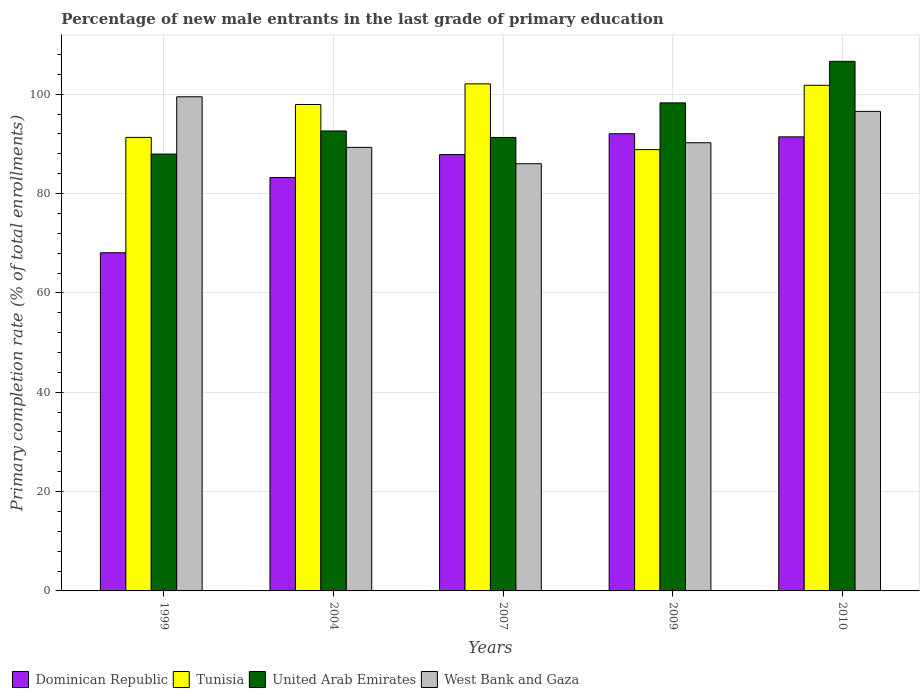How many different coloured bars are there?
Offer a terse response. 4. Are the number of bars on each tick of the X-axis equal?
Your answer should be compact. Yes. What is the label of the 1st group of bars from the left?
Provide a succinct answer. 1999. In how many cases, is the number of bars for a given year not equal to the number of legend labels?
Your response must be concise. 0. What is the percentage of new male entrants in West Bank and Gaza in 2007?
Your answer should be very brief. 86. Across all years, what is the maximum percentage of new male entrants in Tunisia?
Provide a succinct answer. 102.08. Across all years, what is the minimum percentage of new male entrants in Dominican Republic?
Your response must be concise. 68.07. In which year was the percentage of new male entrants in United Arab Emirates maximum?
Give a very brief answer. 2010. In which year was the percentage of new male entrants in West Bank and Gaza minimum?
Your answer should be very brief. 2007. What is the total percentage of new male entrants in United Arab Emirates in the graph?
Offer a very short reply. 476.69. What is the difference between the percentage of new male entrants in West Bank and Gaza in 1999 and that in 2010?
Make the answer very short. 2.94. What is the difference between the percentage of new male entrants in West Bank and Gaza in 2010 and the percentage of new male entrants in Tunisia in 2009?
Your answer should be compact. 7.69. What is the average percentage of new male entrants in United Arab Emirates per year?
Keep it short and to the point. 95.34. In the year 2004, what is the difference between the percentage of new male entrants in United Arab Emirates and percentage of new male entrants in West Bank and Gaza?
Your answer should be very brief. 3.3. What is the ratio of the percentage of new male entrants in Dominican Republic in 1999 to that in 2007?
Provide a succinct answer. 0.77. What is the difference between the highest and the second highest percentage of new male entrants in United Arab Emirates?
Offer a very short reply. 8.36. What is the difference between the highest and the lowest percentage of new male entrants in Tunisia?
Provide a short and direct response. 13.24. In how many years, is the percentage of new male entrants in United Arab Emirates greater than the average percentage of new male entrants in United Arab Emirates taken over all years?
Your answer should be compact. 2. Is the sum of the percentage of new male entrants in West Bank and Gaza in 2007 and 2010 greater than the maximum percentage of new male entrants in Tunisia across all years?
Keep it short and to the point. Yes. What does the 1st bar from the left in 2009 represents?
Offer a very short reply. Dominican Republic. What does the 1st bar from the right in 2009 represents?
Provide a short and direct response. West Bank and Gaza. Is it the case that in every year, the sum of the percentage of new male entrants in Dominican Republic and percentage of new male entrants in West Bank and Gaza is greater than the percentage of new male entrants in Tunisia?
Your response must be concise. Yes. How many bars are there?
Your answer should be compact. 20. Are all the bars in the graph horizontal?
Make the answer very short. No. How many years are there in the graph?
Your response must be concise. 5. Does the graph contain grids?
Your response must be concise. Yes. What is the title of the graph?
Make the answer very short. Percentage of new male entrants in the last grade of primary education. Does "Euro area" appear as one of the legend labels in the graph?
Ensure brevity in your answer.  No. What is the label or title of the X-axis?
Your answer should be compact. Years. What is the label or title of the Y-axis?
Offer a terse response. Primary completion rate (% of total enrollments). What is the Primary completion rate (% of total enrollments) of Dominican Republic in 1999?
Offer a very short reply. 68.07. What is the Primary completion rate (% of total enrollments) of Tunisia in 1999?
Ensure brevity in your answer.  91.3. What is the Primary completion rate (% of total enrollments) of United Arab Emirates in 1999?
Your response must be concise. 87.95. What is the Primary completion rate (% of total enrollments) in West Bank and Gaza in 1999?
Make the answer very short. 99.48. What is the Primary completion rate (% of total enrollments) in Dominican Republic in 2004?
Give a very brief answer. 83.22. What is the Primary completion rate (% of total enrollments) of Tunisia in 2004?
Ensure brevity in your answer.  97.93. What is the Primary completion rate (% of total enrollments) of United Arab Emirates in 2004?
Make the answer very short. 92.6. What is the Primary completion rate (% of total enrollments) in West Bank and Gaza in 2004?
Provide a succinct answer. 89.29. What is the Primary completion rate (% of total enrollments) in Dominican Republic in 2007?
Offer a terse response. 87.84. What is the Primary completion rate (% of total enrollments) of Tunisia in 2007?
Provide a succinct answer. 102.08. What is the Primary completion rate (% of total enrollments) of United Arab Emirates in 2007?
Offer a terse response. 91.29. What is the Primary completion rate (% of total enrollments) of West Bank and Gaza in 2007?
Keep it short and to the point. 86. What is the Primary completion rate (% of total enrollments) of Dominican Republic in 2009?
Provide a short and direct response. 92.04. What is the Primary completion rate (% of total enrollments) in Tunisia in 2009?
Offer a very short reply. 88.84. What is the Primary completion rate (% of total enrollments) of United Arab Emirates in 2009?
Your response must be concise. 98.25. What is the Primary completion rate (% of total enrollments) in West Bank and Gaza in 2009?
Keep it short and to the point. 90.22. What is the Primary completion rate (% of total enrollments) in Dominican Republic in 2010?
Provide a succinct answer. 91.41. What is the Primary completion rate (% of total enrollments) of Tunisia in 2010?
Provide a short and direct response. 101.79. What is the Primary completion rate (% of total enrollments) in United Arab Emirates in 2010?
Your answer should be very brief. 106.61. What is the Primary completion rate (% of total enrollments) of West Bank and Gaza in 2010?
Offer a very short reply. 96.54. Across all years, what is the maximum Primary completion rate (% of total enrollments) in Dominican Republic?
Your answer should be very brief. 92.04. Across all years, what is the maximum Primary completion rate (% of total enrollments) in Tunisia?
Provide a short and direct response. 102.08. Across all years, what is the maximum Primary completion rate (% of total enrollments) of United Arab Emirates?
Provide a short and direct response. 106.61. Across all years, what is the maximum Primary completion rate (% of total enrollments) of West Bank and Gaza?
Your answer should be very brief. 99.48. Across all years, what is the minimum Primary completion rate (% of total enrollments) in Dominican Republic?
Make the answer very short. 68.07. Across all years, what is the minimum Primary completion rate (% of total enrollments) in Tunisia?
Your answer should be very brief. 88.84. Across all years, what is the minimum Primary completion rate (% of total enrollments) of United Arab Emirates?
Provide a short and direct response. 87.95. Across all years, what is the minimum Primary completion rate (% of total enrollments) in West Bank and Gaza?
Your answer should be compact. 86. What is the total Primary completion rate (% of total enrollments) of Dominican Republic in the graph?
Offer a terse response. 422.58. What is the total Primary completion rate (% of total enrollments) of Tunisia in the graph?
Offer a very short reply. 481.94. What is the total Primary completion rate (% of total enrollments) of United Arab Emirates in the graph?
Provide a succinct answer. 476.69. What is the total Primary completion rate (% of total enrollments) of West Bank and Gaza in the graph?
Provide a short and direct response. 461.53. What is the difference between the Primary completion rate (% of total enrollments) in Dominican Republic in 1999 and that in 2004?
Your answer should be compact. -15.15. What is the difference between the Primary completion rate (% of total enrollments) in Tunisia in 1999 and that in 2004?
Keep it short and to the point. -6.62. What is the difference between the Primary completion rate (% of total enrollments) of United Arab Emirates in 1999 and that in 2004?
Offer a very short reply. -4.65. What is the difference between the Primary completion rate (% of total enrollments) of West Bank and Gaza in 1999 and that in 2004?
Offer a terse response. 10.18. What is the difference between the Primary completion rate (% of total enrollments) of Dominican Republic in 1999 and that in 2007?
Offer a terse response. -19.77. What is the difference between the Primary completion rate (% of total enrollments) of Tunisia in 1999 and that in 2007?
Ensure brevity in your answer.  -10.78. What is the difference between the Primary completion rate (% of total enrollments) of United Arab Emirates in 1999 and that in 2007?
Offer a terse response. -3.34. What is the difference between the Primary completion rate (% of total enrollments) of West Bank and Gaza in 1999 and that in 2007?
Your answer should be compact. 13.48. What is the difference between the Primary completion rate (% of total enrollments) of Dominican Republic in 1999 and that in 2009?
Your response must be concise. -23.96. What is the difference between the Primary completion rate (% of total enrollments) in Tunisia in 1999 and that in 2009?
Offer a very short reply. 2.46. What is the difference between the Primary completion rate (% of total enrollments) in United Arab Emirates in 1999 and that in 2009?
Provide a short and direct response. -10.3. What is the difference between the Primary completion rate (% of total enrollments) of West Bank and Gaza in 1999 and that in 2009?
Keep it short and to the point. 9.25. What is the difference between the Primary completion rate (% of total enrollments) of Dominican Republic in 1999 and that in 2010?
Your response must be concise. -23.34. What is the difference between the Primary completion rate (% of total enrollments) in Tunisia in 1999 and that in 2010?
Your response must be concise. -10.49. What is the difference between the Primary completion rate (% of total enrollments) of United Arab Emirates in 1999 and that in 2010?
Provide a succinct answer. -18.66. What is the difference between the Primary completion rate (% of total enrollments) of West Bank and Gaza in 1999 and that in 2010?
Your answer should be compact. 2.94. What is the difference between the Primary completion rate (% of total enrollments) in Dominican Republic in 2004 and that in 2007?
Offer a very short reply. -4.62. What is the difference between the Primary completion rate (% of total enrollments) of Tunisia in 2004 and that in 2007?
Ensure brevity in your answer.  -4.16. What is the difference between the Primary completion rate (% of total enrollments) in United Arab Emirates in 2004 and that in 2007?
Offer a terse response. 1.31. What is the difference between the Primary completion rate (% of total enrollments) of West Bank and Gaza in 2004 and that in 2007?
Your response must be concise. 3.3. What is the difference between the Primary completion rate (% of total enrollments) in Dominican Republic in 2004 and that in 2009?
Offer a very short reply. -8.82. What is the difference between the Primary completion rate (% of total enrollments) in Tunisia in 2004 and that in 2009?
Keep it short and to the point. 9.08. What is the difference between the Primary completion rate (% of total enrollments) in United Arab Emirates in 2004 and that in 2009?
Keep it short and to the point. -5.65. What is the difference between the Primary completion rate (% of total enrollments) in West Bank and Gaza in 2004 and that in 2009?
Ensure brevity in your answer.  -0.93. What is the difference between the Primary completion rate (% of total enrollments) in Dominican Republic in 2004 and that in 2010?
Ensure brevity in your answer.  -8.19. What is the difference between the Primary completion rate (% of total enrollments) of Tunisia in 2004 and that in 2010?
Your answer should be compact. -3.86. What is the difference between the Primary completion rate (% of total enrollments) of United Arab Emirates in 2004 and that in 2010?
Your answer should be very brief. -14.01. What is the difference between the Primary completion rate (% of total enrollments) in West Bank and Gaza in 2004 and that in 2010?
Your answer should be very brief. -7.24. What is the difference between the Primary completion rate (% of total enrollments) of Dominican Republic in 2007 and that in 2009?
Ensure brevity in your answer.  -4.2. What is the difference between the Primary completion rate (% of total enrollments) of Tunisia in 2007 and that in 2009?
Offer a terse response. 13.24. What is the difference between the Primary completion rate (% of total enrollments) of United Arab Emirates in 2007 and that in 2009?
Offer a very short reply. -6.96. What is the difference between the Primary completion rate (% of total enrollments) in West Bank and Gaza in 2007 and that in 2009?
Your answer should be very brief. -4.23. What is the difference between the Primary completion rate (% of total enrollments) in Dominican Republic in 2007 and that in 2010?
Make the answer very short. -3.57. What is the difference between the Primary completion rate (% of total enrollments) of Tunisia in 2007 and that in 2010?
Make the answer very short. 0.29. What is the difference between the Primary completion rate (% of total enrollments) of United Arab Emirates in 2007 and that in 2010?
Keep it short and to the point. -15.32. What is the difference between the Primary completion rate (% of total enrollments) in West Bank and Gaza in 2007 and that in 2010?
Provide a short and direct response. -10.54. What is the difference between the Primary completion rate (% of total enrollments) of Dominican Republic in 2009 and that in 2010?
Your answer should be compact. 0.62. What is the difference between the Primary completion rate (% of total enrollments) in Tunisia in 2009 and that in 2010?
Provide a succinct answer. -12.95. What is the difference between the Primary completion rate (% of total enrollments) in United Arab Emirates in 2009 and that in 2010?
Your answer should be compact. -8.36. What is the difference between the Primary completion rate (% of total enrollments) of West Bank and Gaza in 2009 and that in 2010?
Provide a short and direct response. -6.31. What is the difference between the Primary completion rate (% of total enrollments) in Dominican Republic in 1999 and the Primary completion rate (% of total enrollments) in Tunisia in 2004?
Offer a very short reply. -29.85. What is the difference between the Primary completion rate (% of total enrollments) of Dominican Republic in 1999 and the Primary completion rate (% of total enrollments) of United Arab Emirates in 2004?
Ensure brevity in your answer.  -24.52. What is the difference between the Primary completion rate (% of total enrollments) in Dominican Republic in 1999 and the Primary completion rate (% of total enrollments) in West Bank and Gaza in 2004?
Your answer should be very brief. -21.22. What is the difference between the Primary completion rate (% of total enrollments) in Tunisia in 1999 and the Primary completion rate (% of total enrollments) in United Arab Emirates in 2004?
Keep it short and to the point. -1.29. What is the difference between the Primary completion rate (% of total enrollments) of Tunisia in 1999 and the Primary completion rate (% of total enrollments) of West Bank and Gaza in 2004?
Make the answer very short. 2.01. What is the difference between the Primary completion rate (% of total enrollments) of United Arab Emirates in 1999 and the Primary completion rate (% of total enrollments) of West Bank and Gaza in 2004?
Your answer should be very brief. -1.35. What is the difference between the Primary completion rate (% of total enrollments) of Dominican Republic in 1999 and the Primary completion rate (% of total enrollments) of Tunisia in 2007?
Your answer should be very brief. -34.01. What is the difference between the Primary completion rate (% of total enrollments) of Dominican Republic in 1999 and the Primary completion rate (% of total enrollments) of United Arab Emirates in 2007?
Ensure brevity in your answer.  -23.21. What is the difference between the Primary completion rate (% of total enrollments) in Dominican Republic in 1999 and the Primary completion rate (% of total enrollments) in West Bank and Gaza in 2007?
Your answer should be compact. -17.92. What is the difference between the Primary completion rate (% of total enrollments) in Tunisia in 1999 and the Primary completion rate (% of total enrollments) in United Arab Emirates in 2007?
Ensure brevity in your answer.  0.01. What is the difference between the Primary completion rate (% of total enrollments) in Tunisia in 1999 and the Primary completion rate (% of total enrollments) in West Bank and Gaza in 2007?
Ensure brevity in your answer.  5.3. What is the difference between the Primary completion rate (% of total enrollments) in United Arab Emirates in 1999 and the Primary completion rate (% of total enrollments) in West Bank and Gaza in 2007?
Give a very brief answer. 1.95. What is the difference between the Primary completion rate (% of total enrollments) in Dominican Republic in 1999 and the Primary completion rate (% of total enrollments) in Tunisia in 2009?
Provide a succinct answer. -20.77. What is the difference between the Primary completion rate (% of total enrollments) in Dominican Republic in 1999 and the Primary completion rate (% of total enrollments) in United Arab Emirates in 2009?
Offer a terse response. -30.18. What is the difference between the Primary completion rate (% of total enrollments) in Dominican Republic in 1999 and the Primary completion rate (% of total enrollments) in West Bank and Gaza in 2009?
Your answer should be compact. -22.15. What is the difference between the Primary completion rate (% of total enrollments) of Tunisia in 1999 and the Primary completion rate (% of total enrollments) of United Arab Emirates in 2009?
Make the answer very short. -6.95. What is the difference between the Primary completion rate (% of total enrollments) in Tunisia in 1999 and the Primary completion rate (% of total enrollments) in West Bank and Gaza in 2009?
Offer a very short reply. 1.08. What is the difference between the Primary completion rate (% of total enrollments) in United Arab Emirates in 1999 and the Primary completion rate (% of total enrollments) in West Bank and Gaza in 2009?
Offer a terse response. -2.28. What is the difference between the Primary completion rate (% of total enrollments) in Dominican Republic in 1999 and the Primary completion rate (% of total enrollments) in Tunisia in 2010?
Make the answer very short. -33.72. What is the difference between the Primary completion rate (% of total enrollments) of Dominican Republic in 1999 and the Primary completion rate (% of total enrollments) of United Arab Emirates in 2010?
Your response must be concise. -38.54. What is the difference between the Primary completion rate (% of total enrollments) in Dominican Republic in 1999 and the Primary completion rate (% of total enrollments) in West Bank and Gaza in 2010?
Ensure brevity in your answer.  -28.46. What is the difference between the Primary completion rate (% of total enrollments) of Tunisia in 1999 and the Primary completion rate (% of total enrollments) of United Arab Emirates in 2010?
Your response must be concise. -15.31. What is the difference between the Primary completion rate (% of total enrollments) in Tunisia in 1999 and the Primary completion rate (% of total enrollments) in West Bank and Gaza in 2010?
Your response must be concise. -5.24. What is the difference between the Primary completion rate (% of total enrollments) in United Arab Emirates in 1999 and the Primary completion rate (% of total enrollments) in West Bank and Gaza in 2010?
Ensure brevity in your answer.  -8.59. What is the difference between the Primary completion rate (% of total enrollments) in Dominican Republic in 2004 and the Primary completion rate (% of total enrollments) in Tunisia in 2007?
Your response must be concise. -18.86. What is the difference between the Primary completion rate (% of total enrollments) in Dominican Republic in 2004 and the Primary completion rate (% of total enrollments) in United Arab Emirates in 2007?
Give a very brief answer. -8.07. What is the difference between the Primary completion rate (% of total enrollments) of Dominican Republic in 2004 and the Primary completion rate (% of total enrollments) of West Bank and Gaza in 2007?
Ensure brevity in your answer.  -2.78. What is the difference between the Primary completion rate (% of total enrollments) of Tunisia in 2004 and the Primary completion rate (% of total enrollments) of United Arab Emirates in 2007?
Give a very brief answer. 6.64. What is the difference between the Primary completion rate (% of total enrollments) in Tunisia in 2004 and the Primary completion rate (% of total enrollments) in West Bank and Gaza in 2007?
Offer a very short reply. 11.93. What is the difference between the Primary completion rate (% of total enrollments) in United Arab Emirates in 2004 and the Primary completion rate (% of total enrollments) in West Bank and Gaza in 2007?
Offer a very short reply. 6.6. What is the difference between the Primary completion rate (% of total enrollments) of Dominican Republic in 2004 and the Primary completion rate (% of total enrollments) of Tunisia in 2009?
Provide a short and direct response. -5.62. What is the difference between the Primary completion rate (% of total enrollments) in Dominican Republic in 2004 and the Primary completion rate (% of total enrollments) in United Arab Emirates in 2009?
Offer a very short reply. -15.03. What is the difference between the Primary completion rate (% of total enrollments) of Dominican Republic in 2004 and the Primary completion rate (% of total enrollments) of West Bank and Gaza in 2009?
Provide a succinct answer. -7. What is the difference between the Primary completion rate (% of total enrollments) in Tunisia in 2004 and the Primary completion rate (% of total enrollments) in United Arab Emirates in 2009?
Your response must be concise. -0.32. What is the difference between the Primary completion rate (% of total enrollments) in Tunisia in 2004 and the Primary completion rate (% of total enrollments) in West Bank and Gaza in 2009?
Ensure brevity in your answer.  7.7. What is the difference between the Primary completion rate (% of total enrollments) in United Arab Emirates in 2004 and the Primary completion rate (% of total enrollments) in West Bank and Gaza in 2009?
Ensure brevity in your answer.  2.37. What is the difference between the Primary completion rate (% of total enrollments) of Dominican Republic in 2004 and the Primary completion rate (% of total enrollments) of Tunisia in 2010?
Offer a terse response. -18.57. What is the difference between the Primary completion rate (% of total enrollments) of Dominican Republic in 2004 and the Primary completion rate (% of total enrollments) of United Arab Emirates in 2010?
Ensure brevity in your answer.  -23.39. What is the difference between the Primary completion rate (% of total enrollments) in Dominican Republic in 2004 and the Primary completion rate (% of total enrollments) in West Bank and Gaza in 2010?
Your answer should be compact. -13.32. What is the difference between the Primary completion rate (% of total enrollments) of Tunisia in 2004 and the Primary completion rate (% of total enrollments) of United Arab Emirates in 2010?
Offer a very short reply. -8.68. What is the difference between the Primary completion rate (% of total enrollments) in Tunisia in 2004 and the Primary completion rate (% of total enrollments) in West Bank and Gaza in 2010?
Offer a terse response. 1.39. What is the difference between the Primary completion rate (% of total enrollments) of United Arab Emirates in 2004 and the Primary completion rate (% of total enrollments) of West Bank and Gaza in 2010?
Keep it short and to the point. -3.94. What is the difference between the Primary completion rate (% of total enrollments) of Dominican Republic in 2007 and the Primary completion rate (% of total enrollments) of Tunisia in 2009?
Give a very brief answer. -1.01. What is the difference between the Primary completion rate (% of total enrollments) in Dominican Republic in 2007 and the Primary completion rate (% of total enrollments) in United Arab Emirates in 2009?
Provide a short and direct response. -10.41. What is the difference between the Primary completion rate (% of total enrollments) of Dominican Republic in 2007 and the Primary completion rate (% of total enrollments) of West Bank and Gaza in 2009?
Offer a very short reply. -2.38. What is the difference between the Primary completion rate (% of total enrollments) in Tunisia in 2007 and the Primary completion rate (% of total enrollments) in United Arab Emirates in 2009?
Make the answer very short. 3.83. What is the difference between the Primary completion rate (% of total enrollments) in Tunisia in 2007 and the Primary completion rate (% of total enrollments) in West Bank and Gaza in 2009?
Make the answer very short. 11.86. What is the difference between the Primary completion rate (% of total enrollments) of United Arab Emirates in 2007 and the Primary completion rate (% of total enrollments) of West Bank and Gaza in 2009?
Make the answer very short. 1.06. What is the difference between the Primary completion rate (% of total enrollments) of Dominican Republic in 2007 and the Primary completion rate (% of total enrollments) of Tunisia in 2010?
Provide a short and direct response. -13.95. What is the difference between the Primary completion rate (% of total enrollments) in Dominican Republic in 2007 and the Primary completion rate (% of total enrollments) in United Arab Emirates in 2010?
Your answer should be very brief. -18.77. What is the difference between the Primary completion rate (% of total enrollments) in Dominican Republic in 2007 and the Primary completion rate (% of total enrollments) in West Bank and Gaza in 2010?
Your answer should be very brief. -8.7. What is the difference between the Primary completion rate (% of total enrollments) of Tunisia in 2007 and the Primary completion rate (% of total enrollments) of United Arab Emirates in 2010?
Offer a very short reply. -4.53. What is the difference between the Primary completion rate (% of total enrollments) of Tunisia in 2007 and the Primary completion rate (% of total enrollments) of West Bank and Gaza in 2010?
Give a very brief answer. 5.54. What is the difference between the Primary completion rate (% of total enrollments) of United Arab Emirates in 2007 and the Primary completion rate (% of total enrollments) of West Bank and Gaza in 2010?
Ensure brevity in your answer.  -5.25. What is the difference between the Primary completion rate (% of total enrollments) of Dominican Republic in 2009 and the Primary completion rate (% of total enrollments) of Tunisia in 2010?
Provide a succinct answer. -9.75. What is the difference between the Primary completion rate (% of total enrollments) in Dominican Republic in 2009 and the Primary completion rate (% of total enrollments) in United Arab Emirates in 2010?
Offer a very short reply. -14.57. What is the difference between the Primary completion rate (% of total enrollments) of Dominican Republic in 2009 and the Primary completion rate (% of total enrollments) of West Bank and Gaza in 2010?
Offer a terse response. -4.5. What is the difference between the Primary completion rate (% of total enrollments) in Tunisia in 2009 and the Primary completion rate (% of total enrollments) in United Arab Emirates in 2010?
Provide a succinct answer. -17.77. What is the difference between the Primary completion rate (% of total enrollments) of Tunisia in 2009 and the Primary completion rate (% of total enrollments) of West Bank and Gaza in 2010?
Provide a short and direct response. -7.69. What is the difference between the Primary completion rate (% of total enrollments) of United Arab Emirates in 2009 and the Primary completion rate (% of total enrollments) of West Bank and Gaza in 2010?
Offer a very short reply. 1.71. What is the average Primary completion rate (% of total enrollments) in Dominican Republic per year?
Provide a short and direct response. 84.52. What is the average Primary completion rate (% of total enrollments) in Tunisia per year?
Keep it short and to the point. 96.39. What is the average Primary completion rate (% of total enrollments) in United Arab Emirates per year?
Keep it short and to the point. 95.34. What is the average Primary completion rate (% of total enrollments) of West Bank and Gaza per year?
Provide a succinct answer. 92.31. In the year 1999, what is the difference between the Primary completion rate (% of total enrollments) in Dominican Republic and Primary completion rate (% of total enrollments) in Tunisia?
Give a very brief answer. -23.23. In the year 1999, what is the difference between the Primary completion rate (% of total enrollments) of Dominican Republic and Primary completion rate (% of total enrollments) of United Arab Emirates?
Give a very brief answer. -19.87. In the year 1999, what is the difference between the Primary completion rate (% of total enrollments) in Dominican Republic and Primary completion rate (% of total enrollments) in West Bank and Gaza?
Make the answer very short. -31.4. In the year 1999, what is the difference between the Primary completion rate (% of total enrollments) of Tunisia and Primary completion rate (% of total enrollments) of United Arab Emirates?
Ensure brevity in your answer.  3.35. In the year 1999, what is the difference between the Primary completion rate (% of total enrollments) in Tunisia and Primary completion rate (% of total enrollments) in West Bank and Gaza?
Your answer should be very brief. -8.18. In the year 1999, what is the difference between the Primary completion rate (% of total enrollments) of United Arab Emirates and Primary completion rate (% of total enrollments) of West Bank and Gaza?
Give a very brief answer. -11.53. In the year 2004, what is the difference between the Primary completion rate (% of total enrollments) in Dominican Republic and Primary completion rate (% of total enrollments) in Tunisia?
Offer a very short reply. -14.71. In the year 2004, what is the difference between the Primary completion rate (% of total enrollments) in Dominican Republic and Primary completion rate (% of total enrollments) in United Arab Emirates?
Your answer should be compact. -9.38. In the year 2004, what is the difference between the Primary completion rate (% of total enrollments) in Dominican Republic and Primary completion rate (% of total enrollments) in West Bank and Gaza?
Give a very brief answer. -6.07. In the year 2004, what is the difference between the Primary completion rate (% of total enrollments) of Tunisia and Primary completion rate (% of total enrollments) of United Arab Emirates?
Offer a terse response. 5.33. In the year 2004, what is the difference between the Primary completion rate (% of total enrollments) of Tunisia and Primary completion rate (% of total enrollments) of West Bank and Gaza?
Ensure brevity in your answer.  8.63. In the year 2004, what is the difference between the Primary completion rate (% of total enrollments) of United Arab Emirates and Primary completion rate (% of total enrollments) of West Bank and Gaza?
Offer a very short reply. 3.3. In the year 2007, what is the difference between the Primary completion rate (% of total enrollments) in Dominican Republic and Primary completion rate (% of total enrollments) in Tunisia?
Give a very brief answer. -14.24. In the year 2007, what is the difference between the Primary completion rate (% of total enrollments) of Dominican Republic and Primary completion rate (% of total enrollments) of United Arab Emirates?
Give a very brief answer. -3.45. In the year 2007, what is the difference between the Primary completion rate (% of total enrollments) in Dominican Republic and Primary completion rate (% of total enrollments) in West Bank and Gaza?
Your answer should be compact. 1.84. In the year 2007, what is the difference between the Primary completion rate (% of total enrollments) in Tunisia and Primary completion rate (% of total enrollments) in United Arab Emirates?
Your answer should be compact. 10.79. In the year 2007, what is the difference between the Primary completion rate (% of total enrollments) of Tunisia and Primary completion rate (% of total enrollments) of West Bank and Gaza?
Your answer should be compact. 16.08. In the year 2007, what is the difference between the Primary completion rate (% of total enrollments) in United Arab Emirates and Primary completion rate (% of total enrollments) in West Bank and Gaza?
Your answer should be very brief. 5.29. In the year 2009, what is the difference between the Primary completion rate (% of total enrollments) in Dominican Republic and Primary completion rate (% of total enrollments) in Tunisia?
Give a very brief answer. 3.19. In the year 2009, what is the difference between the Primary completion rate (% of total enrollments) of Dominican Republic and Primary completion rate (% of total enrollments) of United Arab Emirates?
Provide a short and direct response. -6.21. In the year 2009, what is the difference between the Primary completion rate (% of total enrollments) in Dominican Republic and Primary completion rate (% of total enrollments) in West Bank and Gaza?
Offer a very short reply. 1.81. In the year 2009, what is the difference between the Primary completion rate (% of total enrollments) in Tunisia and Primary completion rate (% of total enrollments) in United Arab Emirates?
Offer a very short reply. -9.4. In the year 2009, what is the difference between the Primary completion rate (% of total enrollments) in Tunisia and Primary completion rate (% of total enrollments) in West Bank and Gaza?
Your response must be concise. -1.38. In the year 2009, what is the difference between the Primary completion rate (% of total enrollments) in United Arab Emirates and Primary completion rate (% of total enrollments) in West Bank and Gaza?
Provide a succinct answer. 8.03. In the year 2010, what is the difference between the Primary completion rate (% of total enrollments) in Dominican Republic and Primary completion rate (% of total enrollments) in Tunisia?
Make the answer very short. -10.38. In the year 2010, what is the difference between the Primary completion rate (% of total enrollments) in Dominican Republic and Primary completion rate (% of total enrollments) in United Arab Emirates?
Offer a terse response. -15.2. In the year 2010, what is the difference between the Primary completion rate (% of total enrollments) in Dominican Republic and Primary completion rate (% of total enrollments) in West Bank and Gaza?
Provide a succinct answer. -5.13. In the year 2010, what is the difference between the Primary completion rate (% of total enrollments) of Tunisia and Primary completion rate (% of total enrollments) of United Arab Emirates?
Ensure brevity in your answer.  -4.82. In the year 2010, what is the difference between the Primary completion rate (% of total enrollments) of Tunisia and Primary completion rate (% of total enrollments) of West Bank and Gaza?
Offer a very short reply. 5.25. In the year 2010, what is the difference between the Primary completion rate (% of total enrollments) in United Arab Emirates and Primary completion rate (% of total enrollments) in West Bank and Gaza?
Provide a short and direct response. 10.07. What is the ratio of the Primary completion rate (% of total enrollments) of Dominican Republic in 1999 to that in 2004?
Your answer should be compact. 0.82. What is the ratio of the Primary completion rate (% of total enrollments) in Tunisia in 1999 to that in 2004?
Your response must be concise. 0.93. What is the ratio of the Primary completion rate (% of total enrollments) in United Arab Emirates in 1999 to that in 2004?
Your response must be concise. 0.95. What is the ratio of the Primary completion rate (% of total enrollments) in West Bank and Gaza in 1999 to that in 2004?
Your answer should be compact. 1.11. What is the ratio of the Primary completion rate (% of total enrollments) of Dominican Republic in 1999 to that in 2007?
Give a very brief answer. 0.78. What is the ratio of the Primary completion rate (% of total enrollments) in Tunisia in 1999 to that in 2007?
Provide a short and direct response. 0.89. What is the ratio of the Primary completion rate (% of total enrollments) of United Arab Emirates in 1999 to that in 2007?
Give a very brief answer. 0.96. What is the ratio of the Primary completion rate (% of total enrollments) in West Bank and Gaza in 1999 to that in 2007?
Your response must be concise. 1.16. What is the ratio of the Primary completion rate (% of total enrollments) of Dominican Republic in 1999 to that in 2009?
Give a very brief answer. 0.74. What is the ratio of the Primary completion rate (% of total enrollments) of Tunisia in 1999 to that in 2009?
Give a very brief answer. 1.03. What is the ratio of the Primary completion rate (% of total enrollments) of United Arab Emirates in 1999 to that in 2009?
Your answer should be compact. 0.9. What is the ratio of the Primary completion rate (% of total enrollments) of West Bank and Gaza in 1999 to that in 2009?
Your answer should be compact. 1.1. What is the ratio of the Primary completion rate (% of total enrollments) of Dominican Republic in 1999 to that in 2010?
Provide a succinct answer. 0.74. What is the ratio of the Primary completion rate (% of total enrollments) of Tunisia in 1999 to that in 2010?
Provide a short and direct response. 0.9. What is the ratio of the Primary completion rate (% of total enrollments) of United Arab Emirates in 1999 to that in 2010?
Offer a very short reply. 0.82. What is the ratio of the Primary completion rate (% of total enrollments) in West Bank and Gaza in 1999 to that in 2010?
Your response must be concise. 1.03. What is the ratio of the Primary completion rate (% of total enrollments) in Tunisia in 2004 to that in 2007?
Your answer should be compact. 0.96. What is the ratio of the Primary completion rate (% of total enrollments) in United Arab Emirates in 2004 to that in 2007?
Offer a very short reply. 1.01. What is the ratio of the Primary completion rate (% of total enrollments) of West Bank and Gaza in 2004 to that in 2007?
Your response must be concise. 1.04. What is the ratio of the Primary completion rate (% of total enrollments) in Dominican Republic in 2004 to that in 2009?
Make the answer very short. 0.9. What is the ratio of the Primary completion rate (% of total enrollments) of Tunisia in 2004 to that in 2009?
Offer a very short reply. 1.1. What is the ratio of the Primary completion rate (% of total enrollments) in United Arab Emirates in 2004 to that in 2009?
Offer a very short reply. 0.94. What is the ratio of the Primary completion rate (% of total enrollments) in West Bank and Gaza in 2004 to that in 2009?
Provide a short and direct response. 0.99. What is the ratio of the Primary completion rate (% of total enrollments) of Dominican Republic in 2004 to that in 2010?
Offer a very short reply. 0.91. What is the ratio of the Primary completion rate (% of total enrollments) in Tunisia in 2004 to that in 2010?
Your answer should be very brief. 0.96. What is the ratio of the Primary completion rate (% of total enrollments) in United Arab Emirates in 2004 to that in 2010?
Make the answer very short. 0.87. What is the ratio of the Primary completion rate (% of total enrollments) in West Bank and Gaza in 2004 to that in 2010?
Provide a succinct answer. 0.93. What is the ratio of the Primary completion rate (% of total enrollments) in Dominican Republic in 2007 to that in 2009?
Offer a terse response. 0.95. What is the ratio of the Primary completion rate (% of total enrollments) of Tunisia in 2007 to that in 2009?
Your answer should be very brief. 1.15. What is the ratio of the Primary completion rate (% of total enrollments) of United Arab Emirates in 2007 to that in 2009?
Provide a short and direct response. 0.93. What is the ratio of the Primary completion rate (% of total enrollments) of West Bank and Gaza in 2007 to that in 2009?
Offer a terse response. 0.95. What is the ratio of the Primary completion rate (% of total enrollments) in Dominican Republic in 2007 to that in 2010?
Your answer should be compact. 0.96. What is the ratio of the Primary completion rate (% of total enrollments) in Tunisia in 2007 to that in 2010?
Ensure brevity in your answer.  1. What is the ratio of the Primary completion rate (% of total enrollments) in United Arab Emirates in 2007 to that in 2010?
Ensure brevity in your answer.  0.86. What is the ratio of the Primary completion rate (% of total enrollments) of West Bank and Gaza in 2007 to that in 2010?
Keep it short and to the point. 0.89. What is the ratio of the Primary completion rate (% of total enrollments) of Dominican Republic in 2009 to that in 2010?
Give a very brief answer. 1.01. What is the ratio of the Primary completion rate (% of total enrollments) of Tunisia in 2009 to that in 2010?
Keep it short and to the point. 0.87. What is the ratio of the Primary completion rate (% of total enrollments) in United Arab Emirates in 2009 to that in 2010?
Provide a succinct answer. 0.92. What is the ratio of the Primary completion rate (% of total enrollments) in West Bank and Gaza in 2009 to that in 2010?
Your answer should be very brief. 0.93. What is the difference between the highest and the second highest Primary completion rate (% of total enrollments) in Dominican Republic?
Give a very brief answer. 0.62. What is the difference between the highest and the second highest Primary completion rate (% of total enrollments) in Tunisia?
Your answer should be compact. 0.29. What is the difference between the highest and the second highest Primary completion rate (% of total enrollments) of United Arab Emirates?
Your answer should be compact. 8.36. What is the difference between the highest and the second highest Primary completion rate (% of total enrollments) in West Bank and Gaza?
Ensure brevity in your answer.  2.94. What is the difference between the highest and the lowest Primary completion rate (% of total enrollments) of Dominican Republic?
Your answer should be compact. 23.96. What is the difference between the highest and the lowest Primary completion rate (% of total enrollments) of Tunisia?
Make the answer very short. 13.24. What is the difference between the highest and the lowest Primary completion rate (% of total enrollments) in United Arab Emirates?
Ensure brevity in your answer.  18.66. What is the difference between the highest and the lowest Primary completion rate (% of total enrollments) in West Bank and Gaza?
Keep it short and to the point. 13.48. 